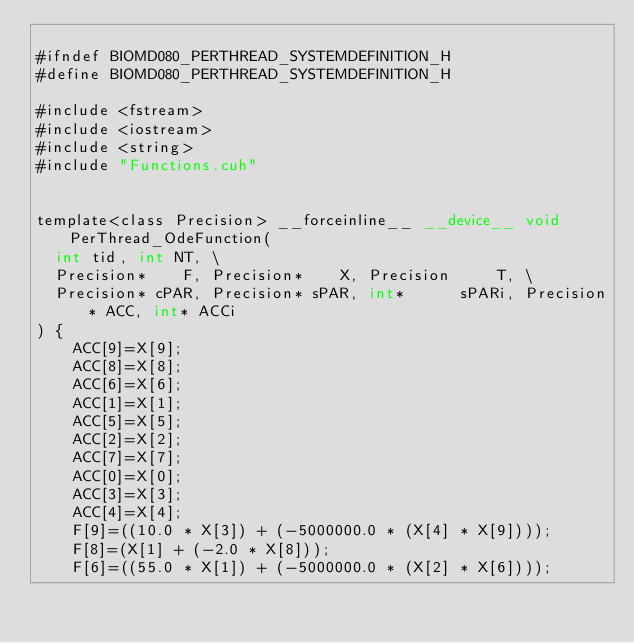Convert code to text. <code><loc_0><loc_0><loc_500><loc_500><_Cuda_>
#ifndef BIOMD080_PERTHREAD_SYSTEMDEFINITION_H
#define BIOMD080_PERTHREAD_SYSTEMDEFINITION_H

#include <fstream>
#include <iostream>
#include <string>
#include "Functions.cuh"


template<class Precision> __forceinline__ __device__ void PerThread_OdeFunction(
	int tid, int NT, \
	Precision*    F, Precision*    X, Precision     T, \
	Precision* cPAR, Precision* sPAR, int*      sPARi, Precision* ACC, int* ACCi  		
) {
    ACC[9]=X[9];
    ACC[8]=X[8];
    ACC[6]=X[6];
    ACC[1]=X[1];
    ACC[5]=X[5];
    ACC[2]=X[2];
    ACC[7]=X[7];
    ACC[0]=X[0];
    ACC[3]=X[3];
    ACC[4]=X[4];
    F[9]=((10.0 * X[3]) + (-5000000.0 * (X[4] * X[9])));
    F[8]=(X[1] + (-2.0 * X[8]));
    F[6]=((55.0 * X[1]) + (-5000000.0 * (X[2] * X[6])));</code> 